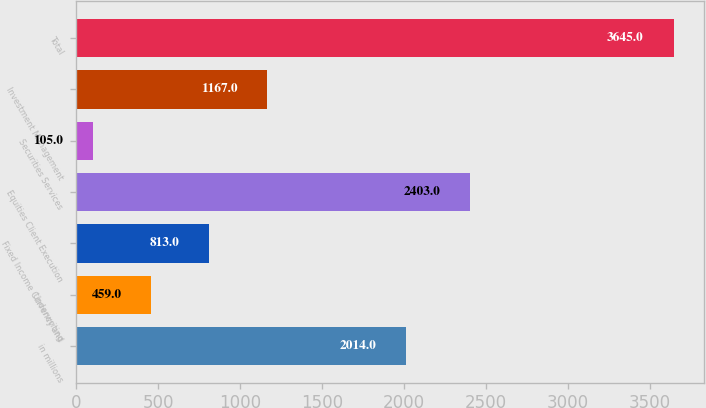Convert chart. <chart><loc_0><loc_0><loc_500><loc_500><bar_chart><fcel>in millions<fcel>Underwriting<fcel>Fixed Income Currency and<fcel>Equities Client Execution<fcel>Securities Services<fcel>Investment Management<fcel>Total<nl><fcel>2014<fcel>459<fcel>813<fcel>2403<fcel>105<fcel>1167<fcel>3645<nl></chart> 